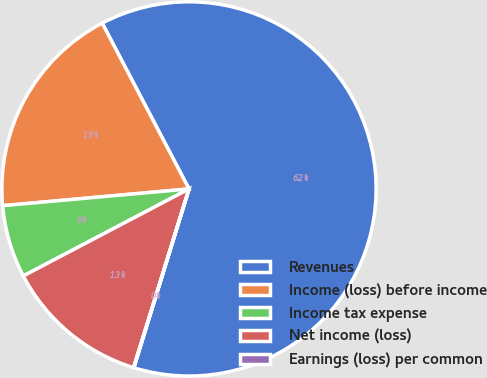Convert chart. <chart><loc_0><loc_0><loc_500><loc_500><pie_chart><fcel>Revenues<fcel>Income (loss) before income<fcel>Income tax expense<fcel>Net income (loss)<fcel>Earnings (loss) per common<nl><fcel>62.43%<fcel>18.75%<fcel>6.27%<fcel>12.51%<fcel>0.03%<nl></chart> 